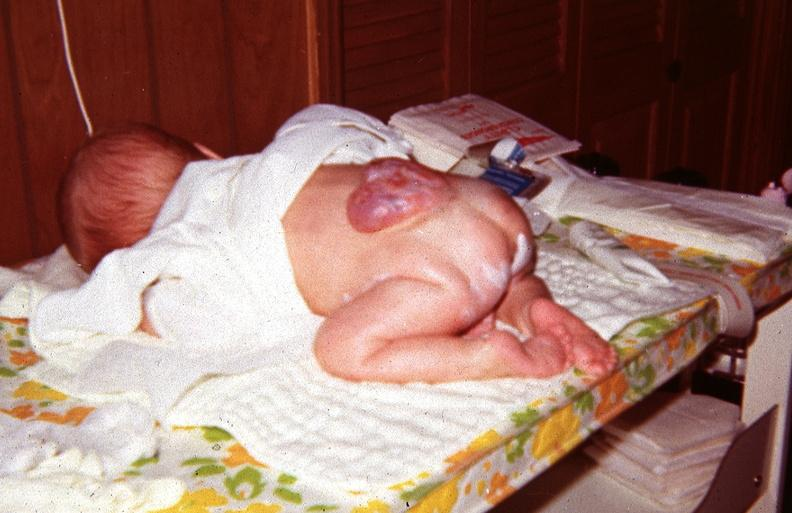what does this image show?
Answer the question using a single word or phrase. Neural tube defect 